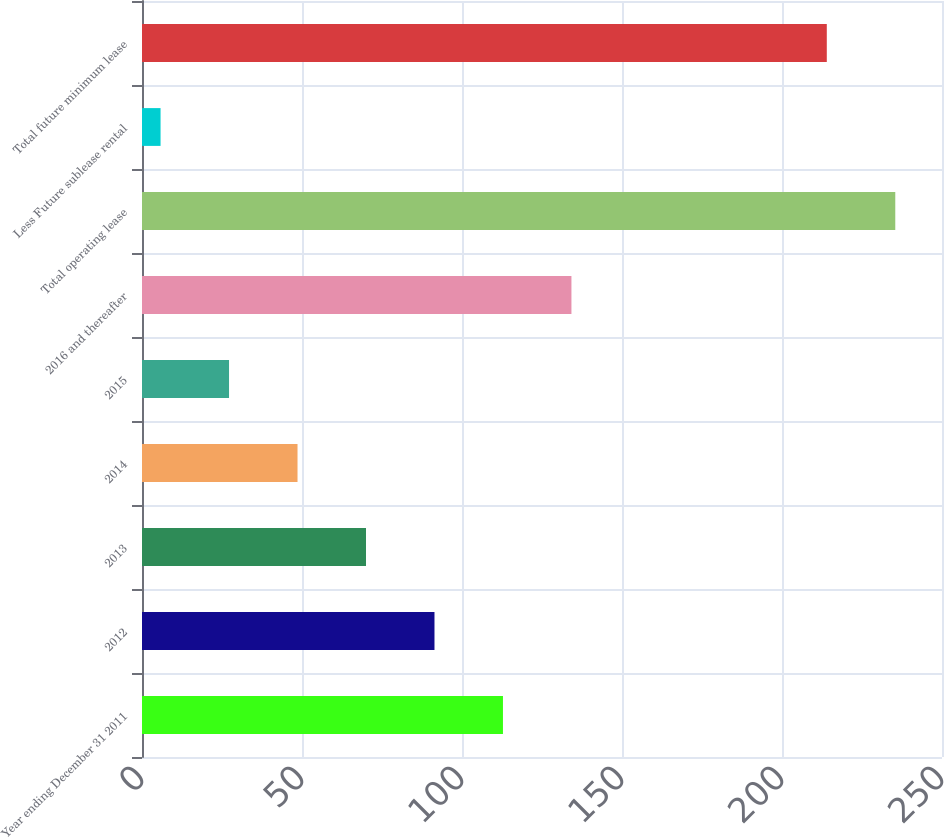<chart> <loc_0><loc_0><loc_500><loc_500><bar_chart><fcel>Year ending December 31 2011<fcel>2012<fcel>2013<fcel>2014<fcel>2015<fcel>2016 and thereafter<fcel>Total operating lease<fcel>Less Future sublease rental<fcel>Total future minimum lease<nl><fcel>112.8<fcel>91.4<fcel>70<fcel>48.6<fcel>27.2<fcel>134.2<fcel>235.4<fcel>5.8<fcel>214<nl></chart> 